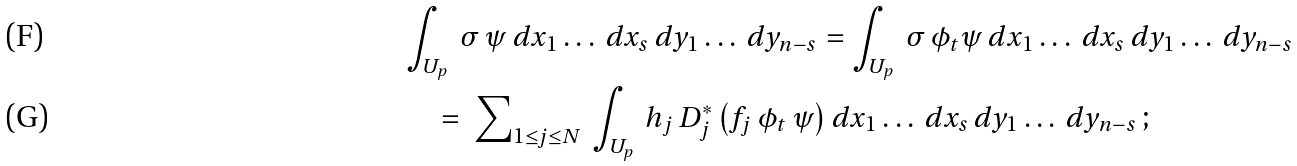Convert formula to latex. <formula><loc_0><loc_0><loc_500><loc_500>& \int _ { U _ { p } } \, \sigma \, \psi \, d x _ { 1 } \dots \, d x _ { s } \, d y _ { 1 } \dots \, d y _ { n - s } = \int _ { U _ { p } } \, \sigma \, \phi _ { t } \psi \, d x _ { 1 } \dots \, d x _ { s } \, d y _ { 1 } \dots \, d y _ { n - s } \\ & \quad = \ { \sum } _ { 1 \leq j \leq N } \, \int _ { U _ { p } } \, h _ { j } \, D ^ { * } _ { j } \left ( f _ { j } \, \phi _ { t } \, \psi \right ) d x _ { 1 } \dots \, d x _ { s } \, d y _ { 1 } \dots \, d y _ { n - s } \, ;</formula> 